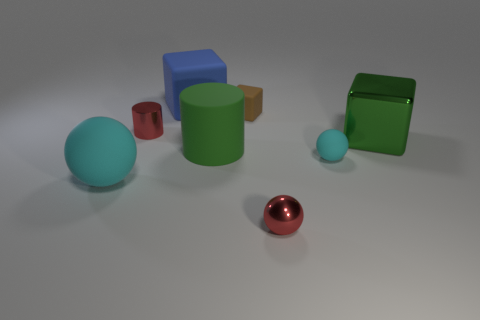Can you describe the texture on the green objects? The green objects in the image exhibit a smooth surface with a reflective quality indicative of a polished or glossy finish, consistent with materials such as painted metal or plastic. 